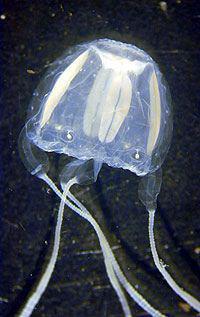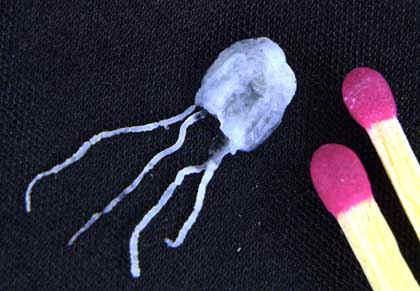The first image is the image on the left, the second image is the image on the right. Examine the images to the left and right. Is the description "The jellyfish on the right is blue and has four tentacles." accurate? Answer yes or no. Yes. 